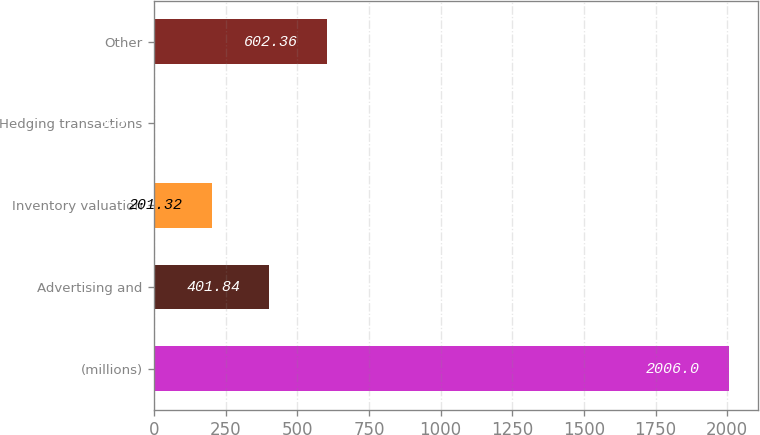Convert chart to OTSL. <chart><loc_0><loc_0><loc_500><loc_500><bar_chart><fcel>(millions)<fcel>Advertising and<fcel>Inventory valuation<fcel>Hedging transactions<fcel>Other<nl><fcel>2006<fcel>401.84<fcel>201.32<fcel>0.8<fcel>602.36<nl></chart> 